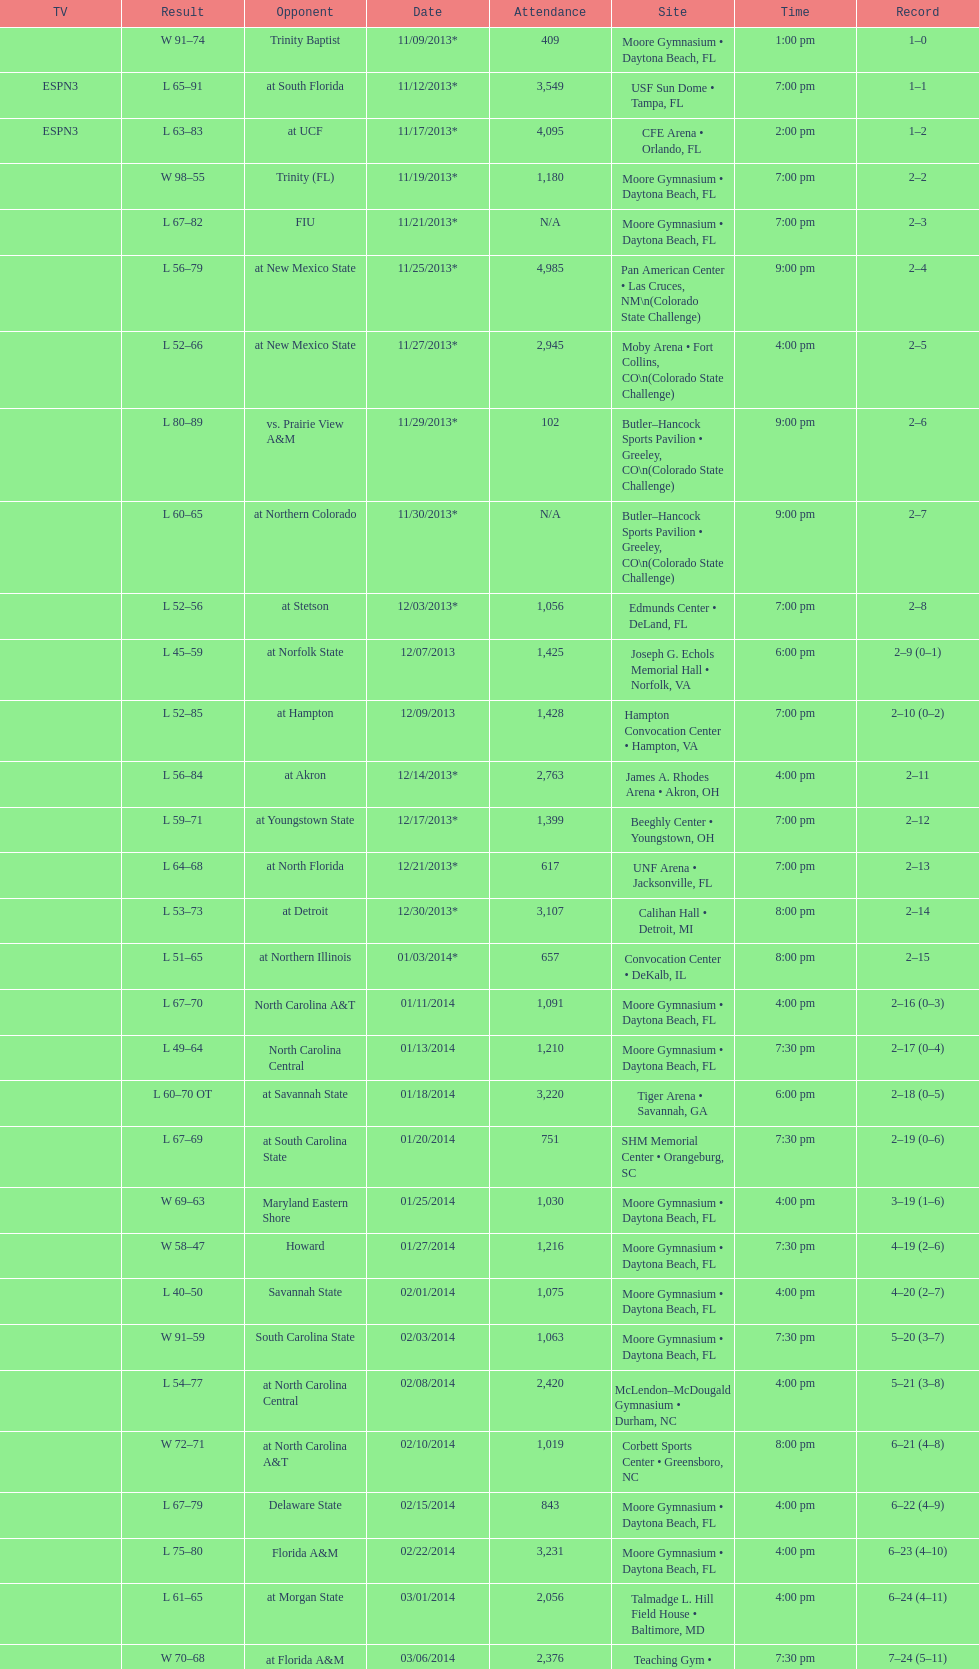What is the number of teams with a maximum attendance of 1,000 or less? 6. Parse the table in full. {'header': ['TV', 'Result', 'Opponent', 'Date', 'Attendance', 'Site', 'Time', 'Record'], 'rows': [['', 'W\xa091–74', 'Trinity Baptist', '11/09/2013*', '409', 'Moore Gymnasium • Daytona Beach, FL', '1:00 pm', '1–0'], ['ESPN3', 'L\xa065–91', 'at\xa0South Florida', '11/12/2013*', '3,549', 'USF Sun Dome • Tampa, FL', '7:00 pm', '1–1'], ['ESPN3', 'L\xa063–83', 'at\xa0UCF', '11/17/2013*', '4,095', 'CFE Arena • Orlando, FL', '2:00 pm', '1–2'], ['', 'W\xa098–55', 'Trinity (FL)', '11/19/2013*', '1,180', 'Moore Gymnasium • Daytona Beach, FL', '7:00 pm', '2–2'], ['', 'L\xa067–82', 'FIU', '11/21/2013*', 'N/A', 'Moore Gymnasium • Daytona Beach, FL', '7:00 pm', '2–3'], ['', 'L\xa056–79', 'at\xa0New Mexico State', '11/25/2013*', '4,985', 'Pan American Center • Las Cruces, NM\\n(Colorado State Challenge)', '9:00 pm', '2–4'], ['', 'L\xa052–66', 'at\xa0New Mexico State', '11/27/2013*', '2,945', 'Moby Arena • Fort Collins, CO\\n(Colorado State Challenge)', '4:00 pm', '2–5'], ['', 'L\xa080–89', 'vs.\xa0Prairie View A&M', '11/29/2013*', '102', 'Butler–Hancock Sports Pavilion • Greeley, CO\\n(Colorado State Challenge)', '9:00 pm', '2–6'], ['', 'L\xa060–65', 'at\xa0Northern Colorado', '11/30/2013*', 'N/A', 'Butler–Hancock Sports Pavilion • Greeley, CO\\n(Colorado State Challenge)', '9:00 pm', '2–7'], ['', 'L\xa052–56', 'at\xa0Stetson', '12/03/2013*', '1,056', 'Edmunds Center • DeLand, FL', '7:00 pm', '2–8'], ['', 'L\xa045–59', 'at\xa0Norfolk State', '12/07/2013', '1,425', 'Joseph G. Echols Memorial Hall • Norfolk, VA', '6:00 pm', '2–9 (0–1)'], ['', 'L\xa052–85', 'at\xa0Hampton', '12/09/2013', '1,428', 'Hampton Convocation Center • Hampton, VA', '7:00 pm', '2–10 (0–2)'], ['', 'L\xa056–84', 'at\xa0Akron', '12/14/2013*', '2,763', 'James A. Rhodes Arena • Akron, OH', '4:00 pm', '2–11'], ['', 'L\xa059–71', 'at\xa0Youngstown State', '12/17/2013*', '1,399', 'Beeghly Center • Youngstown, OH', '7:00 pm', '2–12'], ['', 'L\xa064–68', 'at\xa0North Florida', '12/21/2013*', '617', 'UNF Arena • Jacksonville, FL', '7:00 pm', '2–13'], ['', 'L\xa053–73', 'at\xa0Detroit', '12/30/2013*', '3,107', 'Calihan Hall • Detroit, MI', '8:00 pm', '2–14'], ['', 'L\xa051–65', 'at\xa0Northern Illinois', '01/03/2014*', '657', 'Convocation Center • DeKalb, IL', '8:00 pm', '2–15'], ['', 'L\xa067–70', 'North Carolina A&T', '01/11/2014', '1,091', 'Moore Gymnasium • Daytona Beach, FL', '4:00 pm', '2–16 (0–3)'], ['', 'L\xa049–64', 'North Carolina Central', '01/13/2014', '1,210', 'Moore Gymnasium • Daytona Beach, FL', '7:30 pm', '2–17 (0–4)'], ['', 'L\xa060–70\xa0OT', 'at\xa0Savannah State', '01/18/2014', '3,220', 'Tiger Arena • Savannah, GA', '6:00 pm', '2–18 (0–5)'], ['', 'L\xa067–69', 'at\xa0South Carolina State', '01/20/2014', '751', 'SHM Memorial Center • Orangeburg, SC', '7:30 pm', '2–19 (0–6)'], ['', 'W\xa069–63', 'Maryland Eastern Shore', '01/25/2014', '1,030', 'Moore Gymnasium • Daytona Beach, FL', '4:00 pm', '3–19 (1–6)'], ['', 'W\xa058–47', 'Howard', '01/27/2014', '1,216', 'Moore Gymnasium • Daytona Beach, FL', '7:30 pm', '4–19 (2–6)'], ['', 'L\xa040–50', 'Savannah State', '02/01/2014', '1,075', 'Moore Gymnasium • Daytona Beach, FL', '4:00 pm', '4–20 (2–7)'], ['', 'W\xa091–59', 'South Carolina State', '02/03/2014', '1,063', 'Moore Gymnasium • Daytona Beach, FL', '7:30 pm', '5–20 (3–7)'], ['', 'L\xa054–77', 'at\xa0North Carolina Central', '02/08/2014', '2,420', 'McLendon–McDougald Gymnasium • Durham, NC', '4:00 pm', '5–21 (3–8)'], ['', 'W\xa072–71', 'at\xa0North Carolina A&T', '02/10/2014', '1,019', 'Corbett Sports Center • Greensboro, NC', '8:00 pm', '6–21 (4–8)'], ['', 'L\xa067–79', 'Delaware State', '02/15/2014', '843', 'Moore Gymnasium • Daytona Beach, FL', '4:00 pm', '6–22 (4–9)'], ['', 'L\xa075–80', 'Florida A&M', '02/22/2014', '3,231', 'Moore Gymnasium • Daytona Beach, FL', '4:00 pm', '6–23 (4–10)'], ['', 'L\xa061–65', 'at\xa0Morgan State', '03/01/2014', '2,056', 'Talmadge L. Hill Field House • Baltimore, MD', '4:00 pm', '6–24 (4–11)'], ['', 'W\xa070–68', 'at\xa0Florida A&M', '03/06/2014', '2,376', 'Teaching Gym • Tallahassee, FL', '7:30 pm', '7–24 (5–11)'], ['', 'L\xa068–75', 'vs.\xa0Coppin State', '03/11/2014', '4,658', 'Norfolk Scope • Norfolk, VA\\n(First round)', '6:30 pm', '7–25']]} 